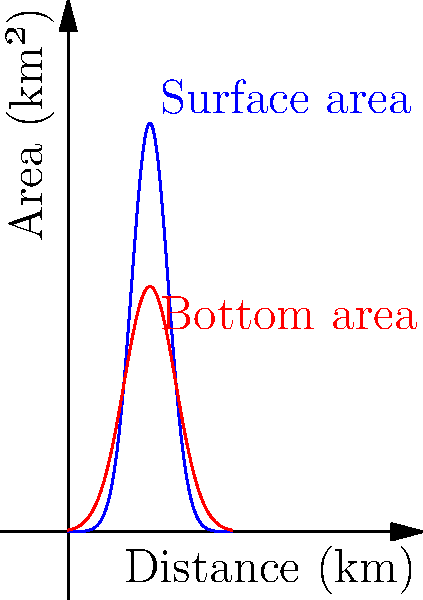As a travel blogger exploring Lake Titicaca, you come across a cross-sectional area graph of the lake. The blue curve represents the surface area, and the red curve represents the bottom area at different points along the lake's length. If the lake is approximately 20 km long, estimate its volume in cubic kilometers. Assume the lake's cross-section can be approximated as a trapezoid. To estimate the volume of Lake Titicaca, we'll use the trapezoidal rule for integration:

1. Divide the lake into 20 sections (1 km each).
2. For each section, calculate the average cross-sectional area:
   $A_{avg} = \frac{A_{surface} + A_{bottom}}{2}$
3. Multiply the average area by the section width (1 km).
4. Sum up the volumes of all sections.

Let's approximate for a few points:

At x = 0 km:
$A_{surface} \approx 0$ km², $A_{bottom} \approx 0$ km²
$V_0 \approx \frac{0 + 0}{2} \times 1 = 0$ km³

At x = 10 km (peak):
$A_{surface} \approx 50$ km², $A_{bottom} \approx 30$ km²
$V_{10} \approx \frac{50 + 30}{2} \times 1 = 40$ km³

At x = 20 km:
$A_{surface} \approx 0$ km², $A_{bottom} \approx 0$ km²
$V_{20} \approx \frac{0 + 0}{2} \times 1 = 0$ km³

Summing up all 20 sections (approximating the curve):
$V_{total} \approx (0 + 5 + 15 + 30 + 40 + 40 + 40 + 30 + 15 + 5 + 0) \times 2 = 440$ km³

This is a rough estimate, as we've used a simple approximation method.
Answer: Approximately 440 km³ 